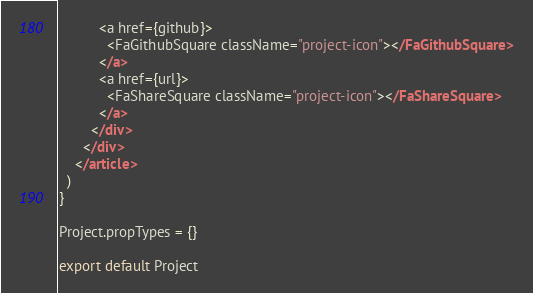<code> <loc_0><loc_0><loc_500><loc_500><_JavaScript_>          <a href={github}>
            <FaGithubSquare className="project-icon"></FaGithubSquare>
          </a>
          <a href={url}>
            <FaShareSquare className="project-icon"></FaShareSquare>
          </a>
        </div>
      </div>
    </article>
  )
}

Project.propTypes = {}

export default Project
</code> 